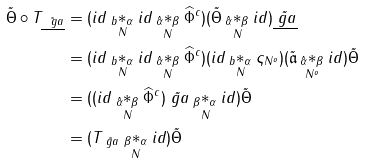Convert formula to latex. <formula><loc_0><loc_0><loc_500><loc_500>\tilde { \Theta } \circ T _ { \tilde { \underline { \ g a } } } & = ( i d \underset { N } { _ { b } * _ { \alpha } } i d \underset { N } { _ { \hat { \alpha } } * _ { \beta } } \widehat { \Phi } ^ { c } ) ( \tilde { \Theta } \underset { N } { _ { \hat { \alpha } } * _ { \beta } } i d ) \tilde { \underline { \ g a } } \\ & = ( i d \underset { N } { _ { b } * _ { \alpha } } i d \underset { N } { _ { \hat { \alpha } } * _ { \beta } } \widehat { \Phi } ^ { c } ) ( i d \underset { N } { _ { b } * _ { \alpha } } \varsigma _ { N ^ { o } } ) ( \tilde { \mathfrak a } \underset { N ^ { o } } { _ { \hat { \alpha } } * _ { \beta } } i d ) \tilde { \Theta } \\ & = ( ( i d \underset { N } { _ { \hat { \alpha } } * _ { \beta } } \widehat { \Phi } ^ { c } ) \tilde { \ g a } \underset { N } { _ { \beta } * _ { \alpha } } i d ) \tilde { \Theta } \\ & = ( T _ { \tilde { \ g a } } \underset { N } { _ { \beta } * _ { \alpha } } i d ) \tilde { \Theta }</formula> 